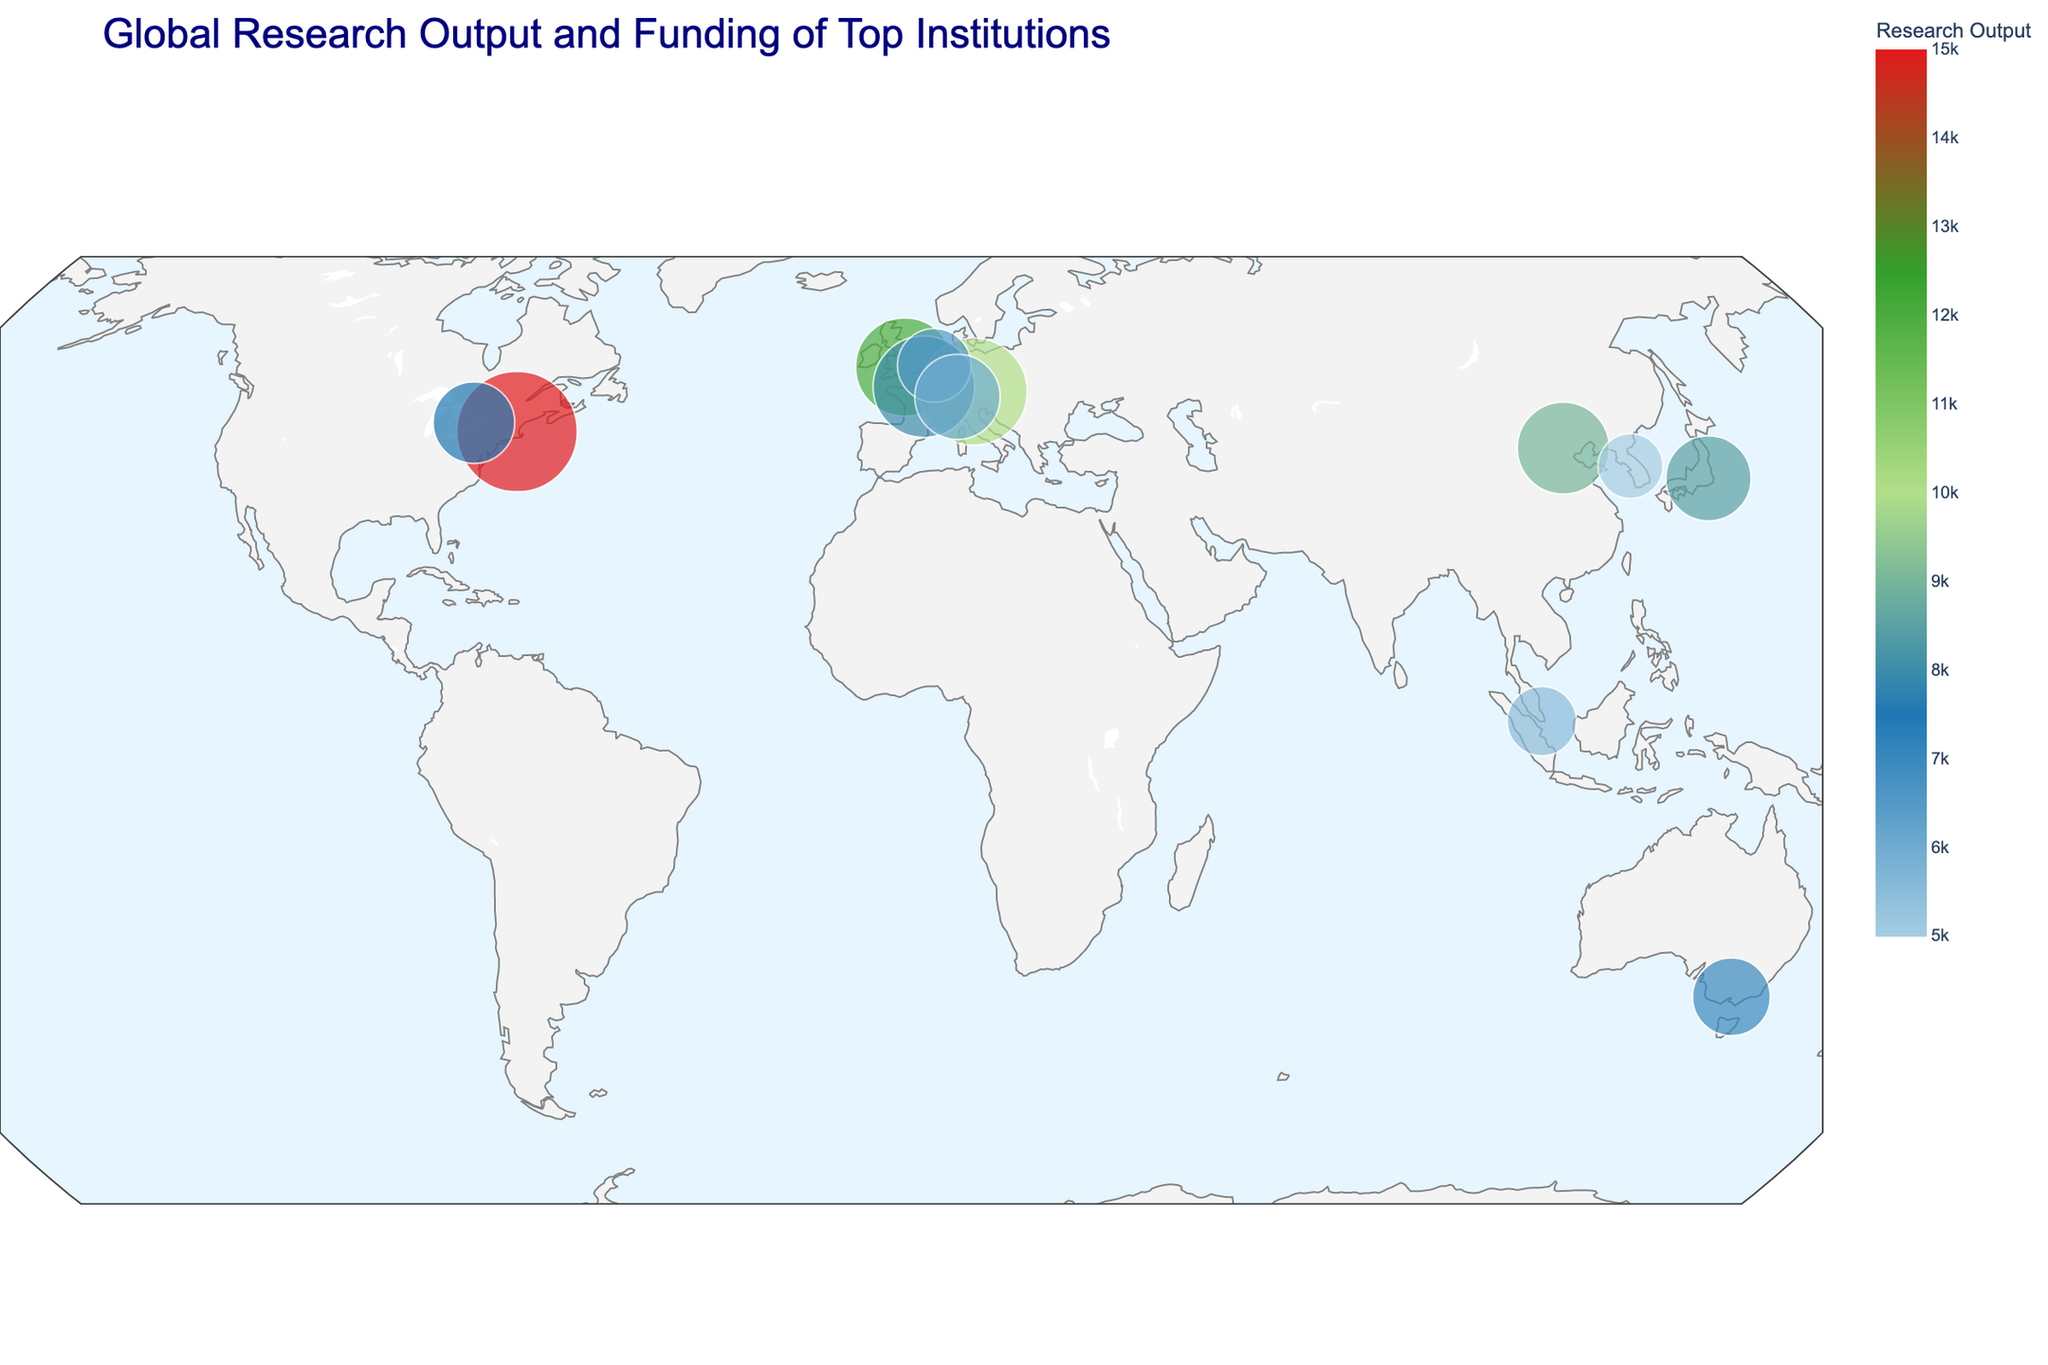What's the title of the figure? The title is typically located at the top center of the figure. In this plot, the title is displayed clearly in a larger, bold font.
Answer: Global Research Output and Funding of Top Institutions How many institutions in total are represented on the map? The total number of institutions can be determined by counting all the unique data points (scatter points) shown on the map. Each point represents one institution.
Answer: 12 Which institution has the highest research output? By looking at the color gradient on the map, the institution with the most saturated color represents the highest research output. According to the plot, darker colors represent higher research outputs.
Answer: Harvard University Which institutions are located in Europe? We need to identify points on the map that are within the European region. Hovering over these points can reveal the specific institutions. Based on the plot locations and hover data, the European institutions are: University of Oxford (United Kingdom), Max Planck Society (Germany), CNRS (France), Delft University of Technology (Netherlands), ETH Zurich (Switzerland).
Answer: University of Oxford, Max Planck Society, CNRS, Delft University of Technology, ETH Zurich What is the combined annual funding for the University of Tokyo and Seoul National University? We add the annual funding figures of both institutions as shown in their hover data. University of Tokyo has $600 million, and Seoul National University has $350 million, so $600M + $350M = $950M.
Answer: $950 million Which institution in Asia has the highest research output? By identifying the points located on the Asian continent and comparing their research output (color intensity), we can determine which institution has the highest figure. The highlighted data points show that Tsinghua University has the highest research output among Asian institutions.
Answer: Tsinghua University What is the ratio of research output to annual funding for the National University of Singapore? This ratio can be calculated using the hover data of the National University of Singapore. Divide the research output (5500) by the annual funding ($400 million) to get 5500/400 = 13.75.
Answer: 13.75 Is the annual funding of the ETH Zurich greater than or equal to the University of Tokyo? By comparing the hover data for both institutions, we find that ETH Zurich has $600 million in annual funding, and the University of Tokyo also has $600 million. 600 is equal to 600.
Answer: Yes How many institutions have an annual funding of over $800 million? By examining the hover data of all institutions, count those which have annual funding exceeding $800 million. Harvard University (1200M), Max Planck Society (950M), and CNRS (850M) all surpass this threshold.
Answer: 3 Which institution has the lowest research output and where is it located? By comparing the lightest color on the map (indicating the lowest research output), we locate the point and hover over it. The institution with the lowest research output, represented by a lighter shade, is Seoul National University in South Korea.
Answer: Seoul National University in South Korea 